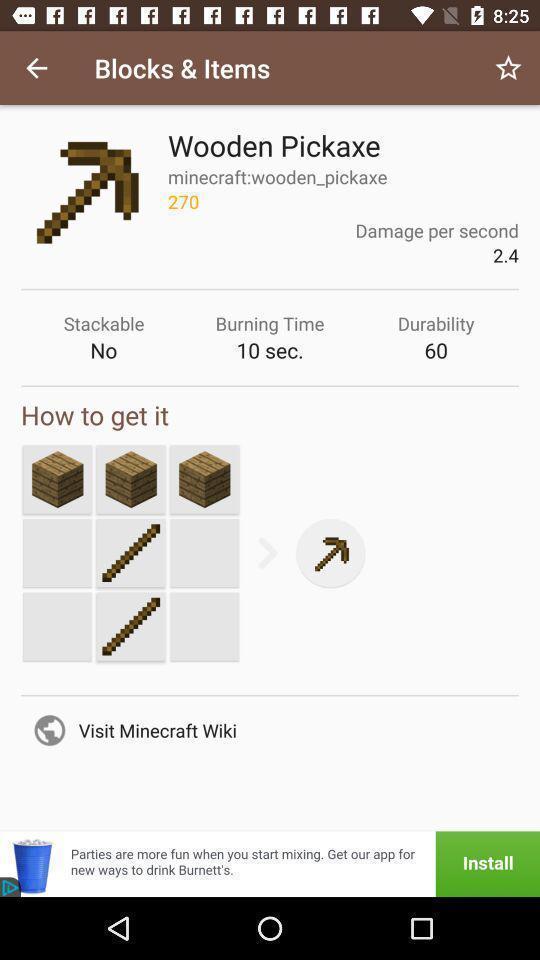Give me a summary of this screen capture. Screen showing blocks and items. 